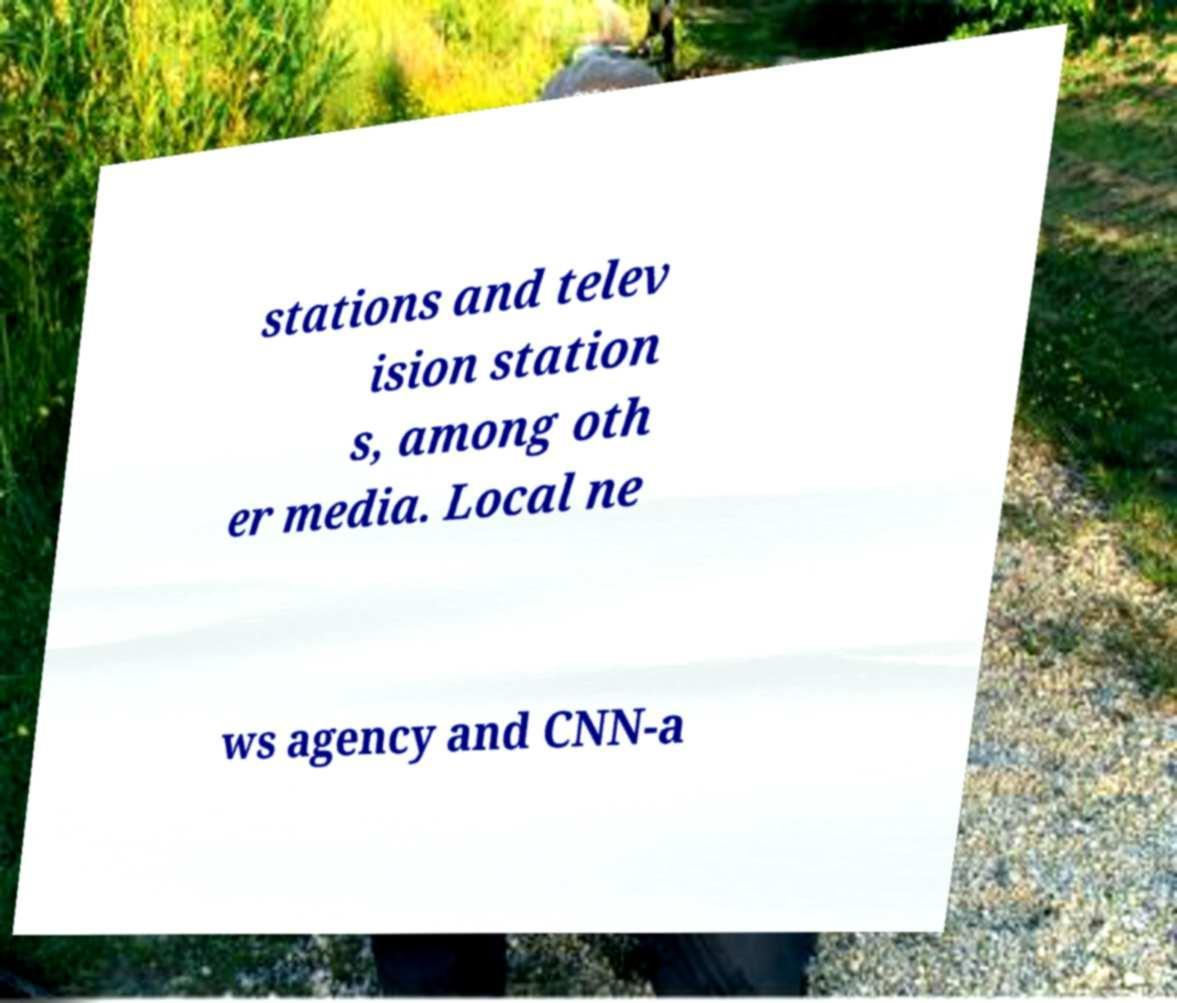Can you read and provide the text displayed in the image?This photo seems to have some interesting text. Can you extract and type it out for me? stations and telev ision station s, among oth er media. Local ne ws agency and CNN-a 